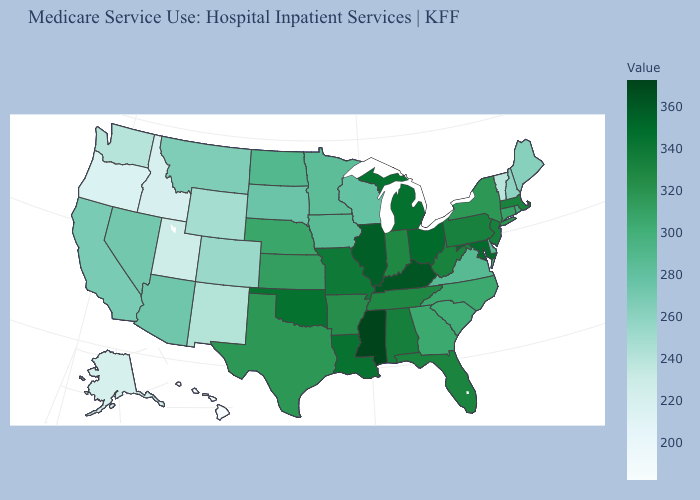Which states have the lowest value in the USA?
Be succinct. Hawaii. Does New Hampshire have a higher value than Oklahoma?
Answer briefly. No. Among the states that border California , which have the lowest value?
Keep it brief. Oregon. Is the legend a continuous bar?
Short answer required. Yes. Which states have the lowest value in the USA?
Short answer required. Hawaii. Is the legend a continuous bar?
Short answer required. Yes. Is the legend a continuous bar?
Answer briefly. Yes. Which states have the lowest value in the South?
Concise answer only. Delaware, Virginia. 